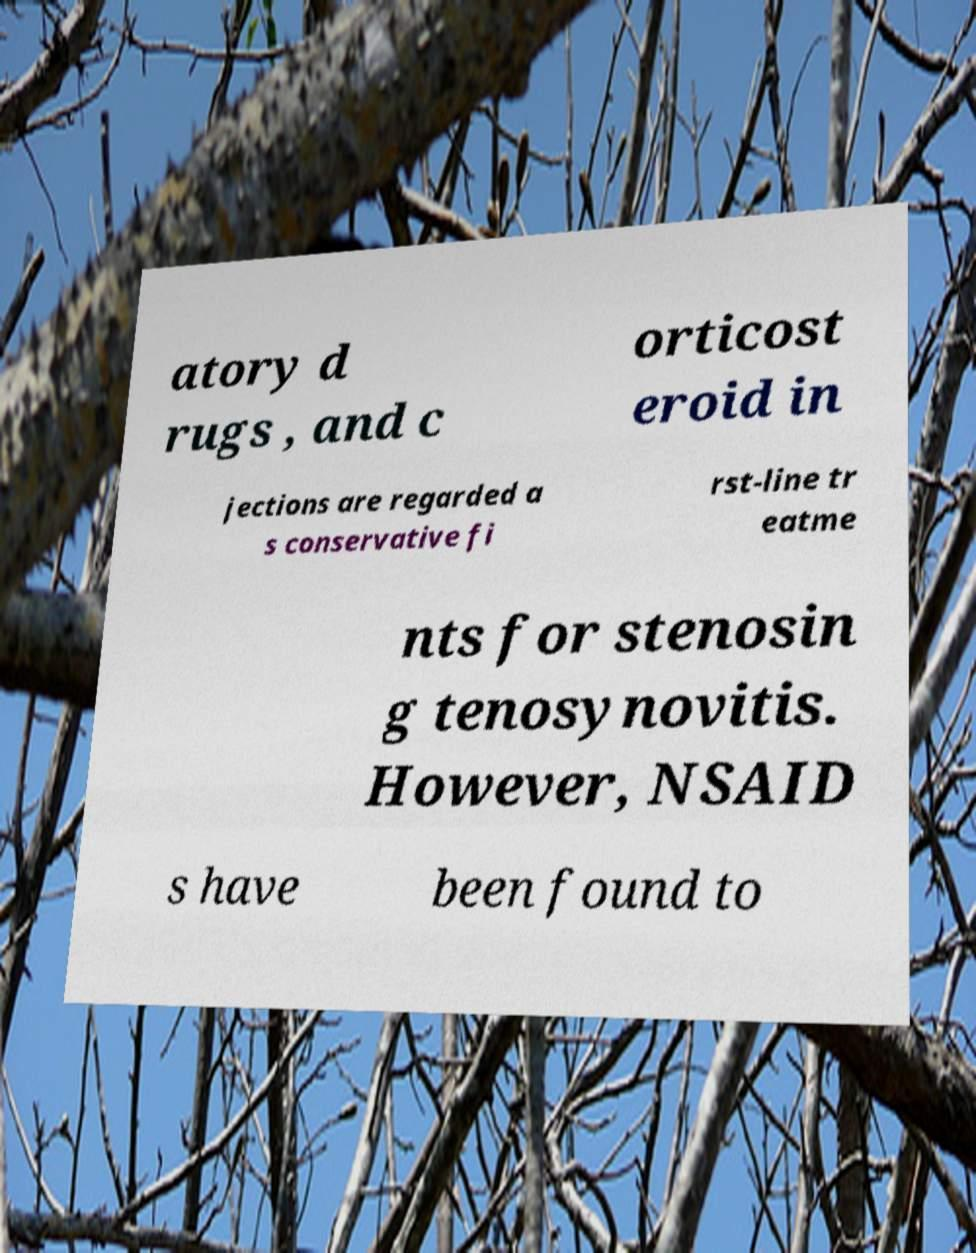Could you assist in decoding the text presented in this image and type it out clearly? atory d rugs , and c orticost eroid in jections are regarded a s conservative fi rst-line tr eatme nts for stenosin g tenosynovitis. However, NSAID s have been found to 